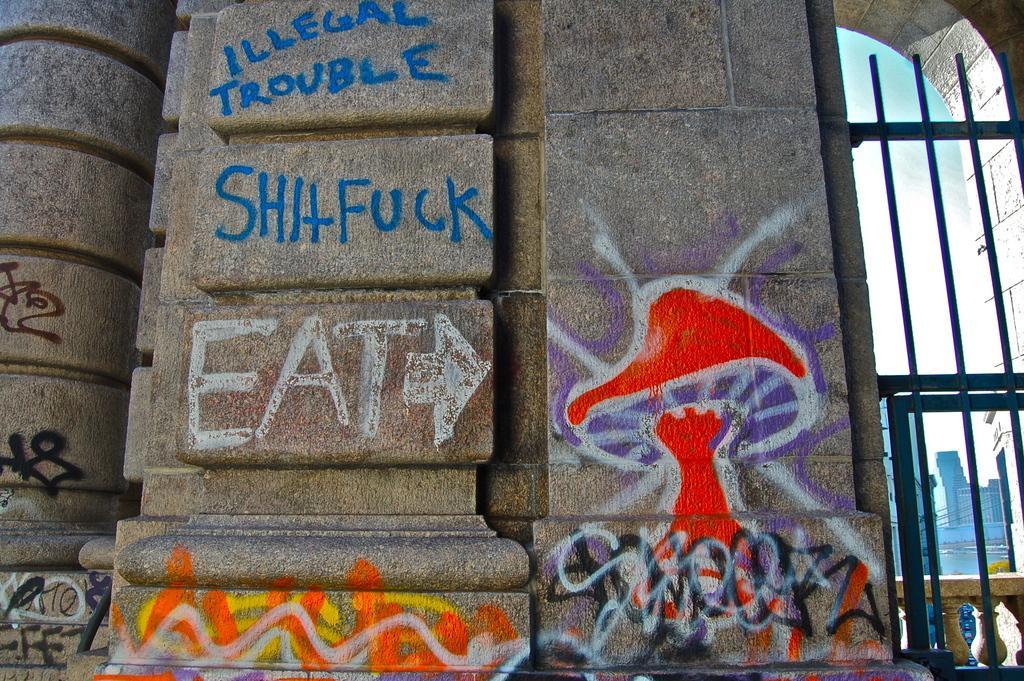In one or two sentences, can you explain what this image depicts? This is the wall. I can see the paintings and letters on the wall. I think this is an iron gate. This looks like an arch. In the background, I can see the buildings. 